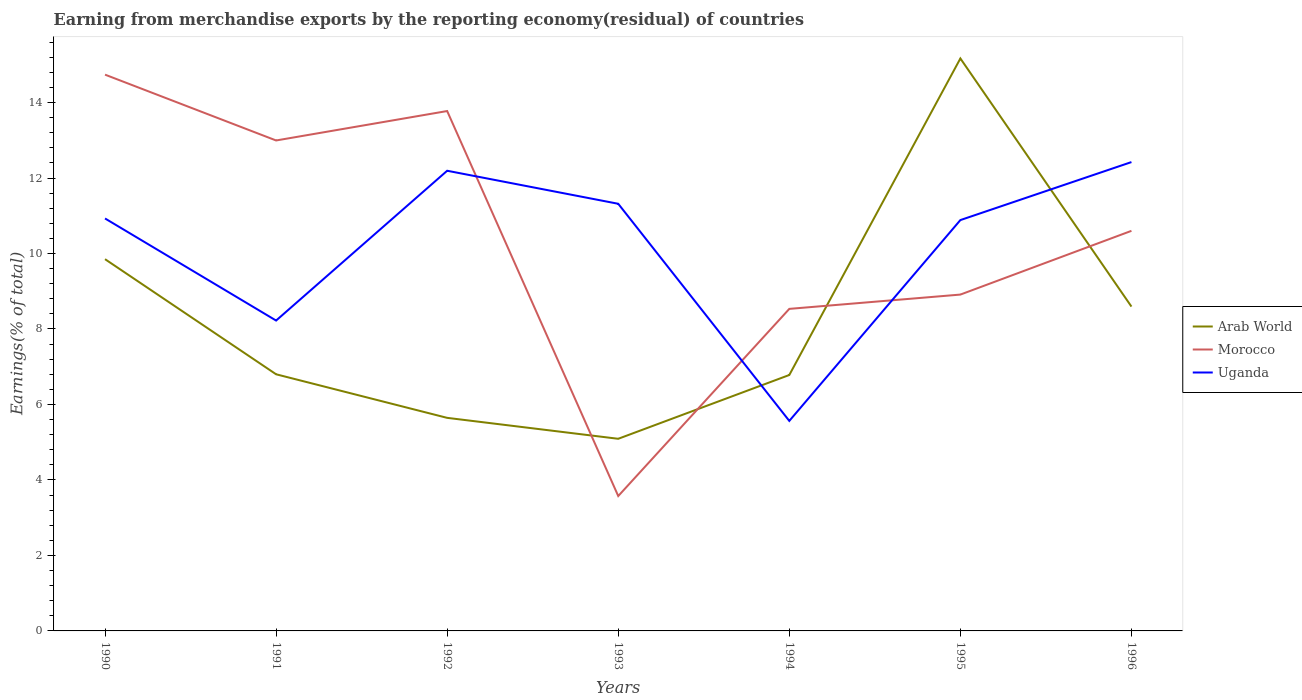How many different coloured lines are there?
Give a very brief answer. 3. Does the line corresponding to Uganda intersect with the line corresponding to Arab World?
Provide a short and direct response. Yes. Is the number of lines equal to the number of legend labels?
Offer a very short reply. Yes. Across all years, what is the maximum percentage of amount earned from merchandise exports in Morocco?
Offer a very short reply. 3.57. In which year was the percentage of amount earned from merchandise exports in Morocco maximum?
Offer a terse response. 1993. What is the total percentage of amount earned from merchandise exports in Morocco in the graph?
Your response must be concise. 5.83. What is the difference between the highest and the second highest percentage of amount earned from merchandise exports in Uganda?
Provide a short and direct response. 6.86. What is the difference between the highest and the lowest percentage of amount earned from merchandise exports in Uganda?
Provide a succinct answer. 5. How many years are there in the graph?
Make the answer very short. 7. Does the graph contain any zero values?
Your answer should be compact. No. How many legend labels are there?
Offer a very short reply. 3. What is the title of the graph?
Offer a terse response. Earning from merchandise exports by the reporting economy(residual) of countries. Does "Macao" appear as one of the legend labels in the graph?
Your response must be concise. No. What is the label or title of the X-axis?
Offer a terse response. Years. What is the label or title of the Y-axis?
Your answer should be compact. Earnings(% of total). What is the Earnings(% of total) of Arab World in 1990?
Keep it short and to the point. 9.85. What is the Earnings(% of total) of Morocco in 1990?
Your answer should be compact. 14.74. What is the Earnings(% of total) of Uganda in 1990?
Offer a terse response. 10.93. What is the Earnings(% of total) in Arab World in 1991?
Your answer should be compact. 6.8. What is the Earnings(% of total) of Morocco in 1991?
Your response must be concise. 12.99. What is the Earnings(% of total) in Uganda in 1991?
Provide a succinct answer. 8.22. What is the Earnings(% of total) in Arab World in 1992?
Offer a very short reply. 5.65. What is the Earnings(% of total) of Morocco in 1992?
Make the answer very short. 13.77. What is the Earnings(% of total) in Uganda in 1992?
Give a very brief answer. 12.19. What is the Earnings(% of total) of Arab World in 1993?
Provide a short and direct response. 5.09. What is the Earnings(% of total) in Morocco in 1993?
Ensure brevity in your answer.  3.57. What is the Earnings(% of total) of Uganda in 1993?
Make the answer very short. 11.32. What is the Earnings(% of total) of Arab World in 1994?
Provide a succinct answer. 6.78. What is the Earnings(% of total) in Morocco in 1994?
Your answer should be very brief. 8.53. What is the Earnings(% of total) of Uganda in 1994?
Your answer should be very brief. 5.56. What is the Earnings(% of total) of Arab World in 1995?
Make the answer very short. 15.17. What is the Earnings(% of total) of Morocco in 1995?
Offer a very short reply. 8.91. What is the Earnings(% of total) in Uganda in 1995?
Your answer should be very brief. 10.89. What is the Earnings(% of total) in Arab World in 1996?
Provide a succinct answer. 8.59. What is the Earnings(% of total) of Morocco in 1996?
Your answer should be compact. 10.6. What is the Earnings(% of total) of Uganda in 1996?
Ensure brevity in your answer.  12.42. Across all years, what is the maximum Earnings(% of total) in Arab World?
Provide a succinct answer. 15.17. Across all years, what is the maximum Earnings(% of total) of Morocco?
Ensure brevity in your answer.  14.74. Across all years, what is the maximum Earnings(% of total) of Uganda?
Offer a very short reply. 12.42. Across all years, what is the minimum Earnings(% of total) of Arab World?
Make the answer very short. 5.09. Across all years, what is the minimum Earnings(% of total) of Morocco?
Offer a terse response. 3.57. Across all years, what is the minimum Earnings(% of total) of Uganda?
Your answer should be very brief. 5.56. What is the total Earnings(% of total) in Arab World in the graph?
Offer a very short reply. 57.93. What is the total Earnings(% of total) in Morocco in the graph?
Give a very brief answer. 73.13. What is the total Earnings(% of total) of Uganda in the graph?
Provide a succinct answer. 71.53. What is the difference between the Earnings(% of total) of Arab World in 1990 and that in 1991?
Make the answer very short. 3.05. What is the difference between the Earnings(% of total) in Morocco in 1990 and that in 1991?
Make the answer very short. 1.74. What is the difference between the Earnings(% of total) of Uganda in 1990 and that in 1991?
Your answer should be compact. 2.7. What is the difference between the Earnings(% of total) in Arab World in 1990 and that in 1992?
Make the answer very short. 4.2. What is the difference between the Earnings(% of total) of Morocco in 1990 and that in 1992?
Provide a short and direct response. 0.96. What is the difference between the Earnings(% of total) in Uganda in 1990 and that in 1992?
Your answer should be compact. -1.26. What is the difference between the Earnings(% of total) in Arab World in 1990 and that in 1993?
Make the answer very short. 4.76. What is the difference between the Earnings(% of total) in Morocco in 1990 and that in 1993?
Provide a succinct answer. 11.16. What is the difference between the Earnings(% of total) of Uganda in 1990 and that in 1993?
Your answer should be compact. -0.39. What is the difference between the Earnings(% of total) of Arab World in 1990 and that in 1994?
Your answer should be compact. 3.07. What is the difference between the Earnings(% of total) of Morocco in 1990 and that in 1994?
Ensure brevity in your answer.  6.21. What is the difference between the Earnings(% of total) in Uganda in 1990 and that in 1994?
Ensure brevity in your answer.  5.36. What is the difference between the Earnings(% of total) of Arab World in 1990 and that in 1995?
Your answer should be compact. -5.32. What is the difference between the Earnings(% of total) in Morocco in 1990 and that in 1995?
Provide a short and direct response. 5.83. What is the difference between the Earnings(% of total) of Uganda in 1990 and that in 1995?
Keep it short and to the point. 0.04. What is the difference between the Earnings(% of total) in Arab World in 1990 and that in 1996?
Give a very brief answer. 1.26. What is the difference between the Earnings(% of total) in Morocco in 1990 and that in 1996?
Ensure brevity in your answer.  4.14. What is the difference between the Earnings(% of total) in Uganda in 1990 and that in 1996?
Give a very brief answer. -1.49. What is the difference between the Earnings(% of total) of Arab World in 1991 and that in 1992?
Provide a succinct answer. 1.15. What is the difference between the Earnings(% of total) of Morocco in 1991 and that in 1992?
Keep it short and to the point. -0.78. What is the difference between the Earnings(% of total) in Uganda in 1991 and that in 1992?
Ensure brevity in your answer.  -3.97. What is the difference between the Earnings(% of total) in Arab World in 1991 and that in 1993?
Provide a succinct answer. 1.71. What is the difference between the Earnings(% of total) in Morocco in 1991 and that in 1993?
Ensure brevity in your answer.  9.42. What is the difference between the Earnings(% of total) in Uganda in 1991 and that in 1993?
Provide a short and direct response. -3.09. What is the difference between the Earnings(% of total) in Arab World in 1991 and that in 1994?
Ensure brevity in your answer.  0.02. What is the difference between the Earnings(% of total) of Morocco in 1991 and that in 1994?
Offer a very short reply. 4.46. What is the difference between the Earnings(% of total) in Uganda in 1991 and that in 1994?
Your answer should be very brief. 2.66. What is the difference between the Earnings(% of total) in Arab World in 1991 and that in 1995?
Keep it short and to the point. -8.37. What is the difference between the Earnings(% of total) of Morocco in 1991 and that in 1995?
Make the answer very short. 4.08. What is the difference between the Earnings(% of total) in Uganda in 1991 and that in 1995?
Your answer should be compact. -2.66. What is the difference between the Earnings(% of total) of Arab World in 1991 and that in 1996?
Your answer should be compact. -1.79. What is the difference between the Earnings(% of total) of Morocco in 1991 and that in 1996?
Your answer should be compact. 2.39. What is the difference between the Earnings(% of total) of Uganda in 1991 and that in 1996?
Provide a succinct answer. -4.2. What is the difference between the Earnings(% of total) of Arab World in 1992 and that in 1993?
Offer a very short reply. 0.55. What is the difference between the Earnings(% of total) of Morocco in 1992 and that in 1993?
Provide a succinct answer. 10.2. What is the difference between the Earnings(% of total) in Uganda in 1992 and that in 1993?
Your answer should be very brief. 0.88. What is the difference between the Earnings(% of total) of Arab World in 1992 and that in 1994?
Provide a succinct answer. -1.14. What is the difference between the Earnings(% of total) of Morocco in 1992 and that in 1994?
Ensure brevity in your answer.  5.24. What is the difference between the Earnings(% of total) in Uganda in 1992 and that in 1994?
Your answer should be very brief. 6.63. What is the difference between the Earnings(% of total) of Arab World in 1992 and that in 1995?
Provide a short and direct response. -9.52. What is the difference between the Earnings(% of total) of Morocco in 1992 and that in 1995?
Offer a terse response. 4.86. What is the difference between the Earnings(% of total) of Uganda in 1992 and that in 1995?
Give a very brief answer. 1.31. What is the difference between the Earnings(% of total) in Arab World in 1992 and that in 1996?
Make the answer very short. -2.95. What is the difference between the Earnings(% of total) in Morocco in 1992 and that in 1996?
Your response must be concise. 3.17. What is the difference between the Earnings(% of total) in Uganda in 1992 and that in 1996?
Give a very brief answer. -0.23. What is the difference between the Earnings(% of total) of Arab World in 1993 and that in 1994?
Offer a very short reply. -1.69. What is the difference between the Earnings(% of total) of Morocco in 1993 and that in 1994?
Offer a terse response. -4.96. What is the difference between the Earnings(% of total) in Uganda in 1993 and that in 1994?
Offer a very short reply. 5.75. What is the difference between the Earnings(% of total) of Arab World in 1993 and that in 1995?
Your answer should be very brief. -10.08. What is the difference between the Earnings(% of total) in Morocco in 1993 and that in 1995?
Give a very brief answer. -5.34. What is the difference between the Earnings(% of total) of Uganda in 1993 and that in 1995?
Your answer should be very brief. 0.43. What is the difference between the Earnings(% of total) in Arab World in 1993 and that in 1996?
Your response must be concise. -3.5. What is the difference between the Earnings(% of total) in Morocco in 1993 and that in 1996?
Offer a very short reply. -7.03. What is the difference between the Earnings(% of total) of Uganda in 1993 and that in 1996?
Ensure brevity in your answer.  -1.1. What is the difference between the Earnings(% of total) of Arab World in 1994 and that in 1995?
Your response must be concise. -8.39. What is the difference between the Earnings(% of total) in Morocco in 1994 and that in 1995?
Your answer should be compact. -0.38. What is the difference between the Earnings(% of total) of Uganda in 1994 and that in 1995?
Offer a terse response. -5.32. What is the difference between the Earnings(% of total) in Arab World in 1994 and that in 1996?
Your answer should be compact. -1.81. What is the difference between the Earnings(% of total) in Morocco in 1994 and that in 1996?
Keep it short and to the point. -2.07. What is the difference between the Earnings(% of total) of Uganda in 1994 and that in 1996?
Give a very brief answer. -6.86. What is the difference between the Earnings(% of total) of Arab World in 1995 and that in 1996?
Provide a short and direct response. 6.57. What is the difference between the Earnings(% of total) in Morocco in 1995 and that in 1996?
Your answer should be compact. -1.69. What is the difference between the Earnings(% of total) in Uganda in 1995 and that in 1996?
Ensure brevity in your answer.  -1.54. What is the difference between the Earnings(% of total) of Arab World in 1990 and the Earnings(% of total) of Morocco in 1991?
Offer a terse response. -3.14. What is the difference between the Earnings(% of total) in Arab World in 1990 and the Earnings(% of total) in Uganda in 1991?
Give a very brief answer. 1.63. What is the difference between the Earnings(% of total) of Morocco in 1990 and the Earnings(% of total) of Uganda in 1991?
Your response must be concise. 6.52. What is the difference between the Earnings(% of total) in Arab World in 1990 and the Earnings(% of total) in Morocco in 1992?
Your response must be concise. -3.92. What is the difference between the Earnings(% of total) of Arab World in 1990 and the Earnings(% of total) of Uganda in 1992?
Ensure brevity in your answer.  -2.34. What is the difference between the Earnings(% of total) of Morocco in 1990 and the Earnings(% of total) of Uganda in 1992?
Give a very brief answer. 2.55. What is the difference between the Earnings(% of total) of Arab World in 1990 and the Earnings(% of total) of Morocco in 1993?
Your response must be concise. 6.28. What is the difference between the Earnings(% of total) of Arab World in 1990 and the Earnings(% of total) of Uganda in 1993?
Make the answer very short. -1.47. What is the difference between the Earnings(% of total) of Morocco in 1990 and the Earnings(% of total) of Uganda in 1993?
Ensure brevity in your answer.  3.42. What is the difference between the Earnings(% of total) in Arab World in 1990 and the Earnings(% of total) in Morocco in 1994?
Provide a short and direct response. 1.32. What is the difference between the Earnings(% of total) in Arab World in 1990 and the Earnings(% of total) in Uganda in 1994?
Keep it short and to the point. 4.29. What is the difference between the Earnings(% of total) in Morocco in 1990 and the Earnings(% of total) in Uganda in 1994?
Offer a very short reply. 9.17. What is the difference between the Earnings(% of total) in Arab World in 1990 and the Earnings(% of total) in Morocco in 1995?
Offer a very short reply. 0.94. What is the difference between the Earnings(% of total) in Arab World in 1990 and the Earnings(% of total) in Uganda in 1995?
Give a very brief answer. -1.04. What is the difference between the Earnings(% of total) in Morocco in 1990 and the Earnings(% of total) in Uganda in 1995?
Offer a very short reply. 3.85. What is the difference between the Earnings(% of total) of Arab World in 1990 and the Earnings(% of total) of Morocco in 1996?
Provide a short and direct response. -0.75. What is the difference between the Earnings(% of total) of Arab World in 1990 and the Earnings(% of total) of Uganda in 1996?
Provide a short and direct response. -2.57. What is the difference between the Earnings(% of total) of Morocco in 1990 and the Earnings(% of total) of Uganda in 1996?
Your answer should be compact. 2.32. What is the difference between the Earnings(% of total) in Arab World in 1991 and the Earnings(% of total) in Morocco in 1992?
Keep it short and to the point. -6.97. What is the difference between the Earnings(% of total) of Arab World in 1991 and the Earnings(% of total) of Uganda in 1992?
Your answer should be very brief. -5.39. What is the difference between the Earnings(% of total) of Morocco in 1991 and the Earnings(% of total) of Uganda in 1992?
Ensure brevity in your answer.  0.8. What is the difference between the Earnings(% of total) in Arab World in 1991 and the Earnings(% of total) in Morocco in 1993?
Make the answer very short. 3.23. What is the difference between the Earnings(% of total) of Arab World in 1991 and the Earnings(% of total) of Uganda in 1993?
Offer a terse response. -4.52. What is the difference between the Earnings(% of total) in Morocco in 1991 and the Earnings(% of total) in Uganda in 1993?
Make the answer very short. 1.68. What is the difference between the Earnings(% of total) of Arab World in 1991 and the Earnings(% of total) of Morocco in 1994?
Provide a succinct answer. -1.73. What is the difference between the Earnings(% of total) in Arab World in 1991 and the Earnings(% of total) in Uganda in 1994?
Keep it short and to the point. 1.24. What is the difference between the Earnings(% of total) of Morocco in 1991 and the Earnings(% of total) of Uganda in 1994?
Your response must be concise. 7.43. What is the difference between the Earnings(% of total) of Arab World in 1991 and the Earnings(% of total) of Morocco in 1995?
Give a very brief answer. -2.11. What is the difference between the Earnings(% of total) in Arab World in 1991 and the Earnings(% of total) in Uganda in 1995?
Your response must be concise. -4.09. What is the difference between the Earnings(% of total) of Morocco in 1991 and the Earnings(% of total) of Uganda in 1995?
Offer a very short reply. 2.11. What is the difference between the Earnings(% of total) in Arab World in 1991 and the Earnings(% of total) in Morocco in 1996?
Offer a very short reply. -3.8. What is the difference between the Earnings(% of total) in Arab World in 1991 and the Earnings(% of total) in Uganda in 1996?
Offer a terse response. -5.62. What is the difference between the Earnings(% of total) in Morocco in 1991 and the Earnings(% of total) in Uganda in 1996?
Your response must be concise. 0.57. What is the difference between the Earnings(% of total) in Arab World in 1992 and the Earnings(% of total) in Morocco in 1993?
Keep it short and to the point. 2.07. What is the difference between the Earnings(% of total) in Arab World in 1992 and the Earnings(% of total) in Uganda in 1993?
Your answer should be compact. -5.67. What is the difference between the Earnings(% of total) of Morocco in 1992 and the Earnings(% of total) of Uganda in 1993?
Keep it short and to the point. 2.46. What is the difference between the Earnings(% of total) of Arab World in 1992 and the Earnings(% of total) of Morocco in 1994?
Ensure brevity in your answer.  -2.89. What is the difference between the Earnings(% of total) of Arab World in 1992 and the Earnings(% of total) of Uganda in 1994?
Provide a succinct answer. 0.08. What is the difference between the Earnings(% of total) in Morocco in 1992 and the Earnings(% of total) in Uganda in 1994?
Give a very brief answer. 8.21. What is the difference between the Earnings(% of total) in Arab World in 1992 and the Earnings(% of total) in Morocco in 1995?
Your answer should be very brief. -3.27. What is the difference between the Earnings(% of total) in Arab World in 1992 and the Earnings(% of total) in Uganda in 1995?
Provide a succinct answer. -5.24. What is the difference between the Earnings(% of total) in Morocco in 1992 and the Earnings(% of total) in Uganda in 1995?
Make the answer very short. 2.89. What is the difference between the Earnings(% of total) of Arab World in 1992 and the Earnings(% of total) of Morocco in 1996?
Offer a very short reply. -4.95. What is the difference between the Earnings(% of total) of Arab World in 1992 and the Earnings(% of total) of Uganda in 1996?
Offer a terse response. -6.78. What is the difference between the Earnings(% of total) of Morocco in 1992 and the Earnings(% of total) of Uganda in 1996?
Offer a terse response. 1.35. What is the difference between the Earnings(% of total) of Arab World in 1993 and the Earnings(% of total) of Morocco in 1994?
Keep it short and to the point. -3.44. What is the difference between the Earnings(% of total) of Arab World in 1993 and the Earnings(% of total) of Uganda in 1994?
Offer a very short reply. -0.47. What is the difference between the Earnings(% of total) of Morocco in 1993 and the Earnings(% of total) of Uganda in 1994?
Your answer should be very brief. -1.99. What is the difference between the Earnings(% of total) in Arab World in 1993 and the Earnings(% of total) in Morocco in 1995?
Provide a short and direct response. -3.82. What is the difference between the Earnings(% of total) in Arab World in 1993 and the Earnings(% of total) in Uganda in 1995?
Provide a short and direct response. -5.79. What is the difference between the Earnings(% of total) of Morocco in 1993 and the Earnings(% of total) of Uganda in 1995?
Your response must be concise. -7.31. What is the difference between the Earnings(% of total) of Arab World in 1993 and the Earnings(% of total) of Morocco in 1996?
Your answer should be compact. -5.51. What is the difference between the Earnings(% of total) of Arab World in 1993 and the Earnings(% of total) of Uganda in 1996?
Ensure brevity in your answer.  -7.33. What is the difference between the Earnings(% of total) of Morocco in 1993 and the Earnings(% of total) of Uganda in 1996?
Ensure brevity in your answer.  -8.85. What is the difference between the Earnings(% of total) in Arab World in 1994 and the Earnings(% of total) in Morocco in 1995?
Offer a terse response. -2.13. What is the difference between the Earnings(% of total) in Arab World in 1994 and the Earnings(% of total) in Uganda in 1995?
Provide a succinct answer. -4.1. What is the difference between the Earnings(% of total) in Morocco in 1994 and the Earnings(% of total) in Uganda in 1995?
Offer a terse response. -2.35. What is the difference between the Earnings(% of total) in Arab World in 1994 and the Earnings(% of total) in Morocco in 1996?
Your answer should be compact. -3.82. What is the difference between the Earnings(% of total) of Arab World in 1994 and the Earnings(% of total) of Uganda in 1996?
Provide a short and direct response. -5.64. What is the difference between the Earnings(% of total) in Morocco in 1994 and the Earnings(% of total) in Uganda in 1996?
Offer a terse response. -3.89. What is the difference between the Earnings(% of total) of Arab World in 1995 and the Earnings(% of total) of Morocco in 1996?
Give a very brief answer. 4.57. What is the difference between the Earnings(% of total) in Arab World in 1995 and the Earnings(% of total) in Uganda in 1996?
Offer a very short reply. 2.75. What is the difference between the Earnings(% of total) of Morocco in 1995 and the Earnings(% of total) of Uganda in 1996?
Your answer should be very brief. -3.51. What is the average Earnings(% of total) in Arab World per year?
Your response must be concise. 8.28. What is the average Earnings(% of total) of Morocco per year?
Provide a short and direct response. 10.45. What is the average Earnings(% of total) in Uganda per year?
Your answer should be very brief. 10.22. In the year 1990, what is the difference between the Earnings(% of total) of Arab World and Earnings(% of total) of Morocco?
Offer a terse response. -4.89. In the year 1990, what is the difference between the Earnings(% of total) of Arab World and Earnings(% of total) of Uganda?
Provide a succinct answer. -1.08. In the year 1990, what is the difference between the Earnings(% of total) of Morocco and Earnings(% of total) of Uganda?
Your answer should be very brief. 3.81. In the year 1991, what is the difference between the Earnings(% of total) of Arab World and Earnings(% of total) of Morocco?
Your response must be concise. -6.19. In the year 1991, what is the difference between the Earnings(% of total) of Arab World and Earnings(% of total) of Uganda?
Keep it short and to the point. -1.42. In the year 1991, what is the difference between the Earnings(% of total) in Morocco and Earnings(% of total) in Uganda?
Make the answer very short. 4.77. In the year 1992, what is the difference between the Earnings(% of total) of Arab World and Earnings(% of total) of Morocco?
Your response must be concise. -8.13. In the year 1992, what is the difference between the Earnings(% of total) of Arab World and Earnings(% of total) of Uganda?
Provide a short and direct response. -6.55. In the year 1992, what is the difference between the Earnings(% of total) in Morocco and Earnings(% of total) in Uganda?
Provide a succinct answer. 1.58. In the year 1993, what is the difference between the Earnings(% of total) in Arab World and Earnings(% of total) in Morocco?
Your response must be concise. 1.52. In the year 1993, what is the difference between the Earnings(% of total) in Arab World and Earnings(% of total) in Uganda?
Your answer should be very brief. -6.23. In the year 1993, what is the difference between the Earnings(% of total) in Morocco and Earnings(% of total) in Uganda?
Provide a succinct answer. -7.74. In the year 1994, what is the difference between the Earnings(% of total) in Arab World and Earnings(% of total) in Morocco?
Make the answer very short. -1.75. In the year 1994, what is the difference between the Earnings(% of total) in Arab World and Earnings(% of total) in Uganda?
Ensure brevity in your answer.  1.22. In the year 1994, what is the difference between the Earnings(% of total) in Morocco and Earnings(% of total) in Uganda?
Give a very brief answer. 2.97. In the year 1995, what is the difference between the Earnings(% of total) of Arab World and Earnings(% of total) of Morocco?
Offer a terse response. 6.26. In the year 1995, what is the difference between the Earnings(% of total) in Arab World and Earnings(% of total) in Uganda?
Your answer should be very brief. 4.28. In the year 1995, what is the difference between the Earnings(% of total) in Morocco and Earnings(% of total) in Uganda?
Provide a succinct answer. -1.97. In the year 1996, what is the difference between the Earnings(% of total) of Arab World and Earnings(% of total) of Morocco?
Keep it short and to the point. -2.01. In the year 1996, what is the difference between the Earnings(% of total) of Arab World and Earnings(% of total) of Uganda?
Your answer should be compact. -3.83. In the year 1996, what is the difference between the Earnings(% of total) in Morocco and Earnings(% of total) in Uganda?
Offer a terse response. -1.82. What is the ratio of the Earnings(% of total) in Arab World in 1990 to that in 1991?
Offer a terse response. 1.45. What is the ratio of the Earnings(% of total) in Morocco in 1990 to that in 1991?
Give a very brief answer. 1.13. What is the ratio of the Earnings(% of total) of Uganda in 1990 to that in 1991?
Provide a short and direct response. 1.33. What is the ratio of the Earnings(% of total) of Arab World in 1990 to that in 1992?
Your response must be concise. 1.74. What is the ratio of the Earnings(% of total) in Morocco in 1990 to that in 1992?
Offer a very short reply. 1.07. What is the ratio of the Earnings(% of total) in Uganda in 1990 to that in 1992?
Give a very brief answer. 0.9. What is the ratio of the Earnings(% of total) of Arab World in 1990 to that in 1993?
Offer a terse response. 1.93. What is the ratio of the Earnings(% of total) of Morocco in 1990 to that in 1993?
Your response must be concise. 4.12. What is the ratio of the Earnings(% of total) in Uganda in 1990 to that in 1993?
Keep it short and to the point. 0.97. What is the ratio of the Earnings(% of total) in Arab World in 1990 to that in 1994?
Provide a succinct answer. 1.45. What is the ratio of the Earnings(% of total) of Morocco in 1990 to that in 1994?
Provide a short and direct response. 1.73. What is the ratio of the Earnings(% of total) in Uganda in 1990 to that in 1994?
Ensure brevity in your answer.  1.96. What is the ratio of the Earnings(% of total) of Arab World in 1990 to that in 1995?
Your answer should be very brief. 0.65. What is the ratio of the Earnings(% of total) in Morocco in 1990 to that in 1995?
Your answer should be compact. 1.65. What is the ratio of the Earnings(% of total) of Arab World in 1990 to that in 1996?
Keep it short and to the point. 1.15. What is the ratio of the Earnings(% of total) in Morocco in 1990 to that in 1996?
Offer a very short reply. 1.39. What is the ratio of the Earnings(% of total) in Uganda in 1990 to that in 1996?
Your answer should be very brief. 0.88. What is the ratio of the Earnings(% of total) of Arab World in 1991 to that in 1992?
Offer a terse response. 1.2. What is the ratio of the Earnings(% of total) in Morocco in 1991 to that in 1992?
Make the answer very short. 0.94. What is the ratio of the Earnings(% of total) of Uganda in 1991 to that in 1992?
Keep it short and to the point. 0.67. What is the ratio of the Earnings(% of total) in Arab World in 1991 to that in 1993?
Ensure brevity in your answer.  1.34. What is the ratio of the Earnings(% of total) of Morocco in 1991 to that in 1993?
Your answer should be very brief. 3.64. What is the ratio of the Earnings(% of total) in Uganda in 1991 to that in 1993?
Your response must be concise. 0.73. What is the ratio of the Earnings(% of total) of Morocco in 1991 to that in 1994?
Your answer should be compact. 1.52. What is the ratio of the Earnings(% of total) in Uganda in 1991 to that in 1994?
Provide a short and direct response. 1.48. What is the ratio of the Earnings(% of total) of Arab World in 1991 to that in 1995?
Provide a succinct answer. 0.45. What is the ratio of the Earnings(% of total) of Morocco in 1991 to that in 1995?
Provide a succinct answer. 1.46. What is the ratio of the Earnings(% of total) in Uganda in 1991 to that in 1995?
Provide a succinct answer. 0.76. What is the ratio of the Earnings(% of total) of Arab World in 1991 to that in 1996?
Provide a succinct answer. 0.79. What is the ratio of the Earnings(% of total) in Morocco in 1991 to that in 1996?
Ensure brevity in your answer.  1.23. What is the ratio of the Earnings(% of total) of Uganda in 1991 to that in 1996?
Ensure brevity in your answer.  0.66. What is the ratio of the Earnings(% of total) of Arab World in 1992 to that in 1993?
Your answer should be compact. 1.11. What is the ratio of the Earnings(% of total) of Morocco in 1992 to that in 1993?
Give a very brief answer. 3.85. What is the ratio of the Earnings(% of total) of Uganda in 1992 to that in 1993?
Offer a terse response. 1.08. What is the ratio of the Earnings(% of total) in Arab World in 1992 to that in 1994?
Keep it short and to the point. 0.83. What is the ratio of the Earnings(% of total) of Morocco in 1992 to that in 1994?
Your answer should be very brief. 1.61. What is the ratio of the Earnings(% of total) in Uganda in 1992 to that in 1994?
Your answer should be compact. 2.19. What is the ratio of the Earnings(% of total) in Arab World in 1992 to that in 1995?
Offer a very short reply. 0.37. What is the ratio of the Earnings(% of total) in Morocco in 1992 to that in 1995?
Make the answer very short. 1.55. What is the ratio of the Earnings(% of total) in Uganda in 1992 to that in 1995?
Provide a succinct answer. 1.12. What is the ratio of the Earnings(% of total) of Arab World in 1992 to that in 1996?
Provide a succinct answer. 0.66. What is the ratio of the Earnings(% of total) in Morocco in 1992 to that in 1996?
Your answer should be very brief. 1.3. What is the ratio of the Earnings(% of total) in Uganda in 1992 to that in 1996?
Your answer should be very brief. 0.98. What is the ratio of the Earnings(% of total) of Arab World in 1993 to that in 1994?
Provide a short and direct response. 0.75. What is the ratio of the Earnings(% of total) of Morocco in 1993 to that in 1994?
Your answer should be very brief. 0.42. What is the ratio of the Earnings(% of total) in Uganda in 1993 to that in 1994?
Give a very brief answer. 2.03. What is the ratio of the Earnings(% of total) of Arab World in 1993 to that in 1995?
Ensure brevity in your answer.  0.34. What is the ratio of the Earnings(% of total) in Morocco in 1993 to that in 1995?
Offer a terse response. 0.4. What is the ratio of the Earnings(% of total) in Uganda in 1993 to that in 1995?
Provide a short and direct response. 1.04. What is the ratio of the Earnings(% of total) in Arab World in 1993 to that in 1996?
Give a very brief answer. 0.59. What is the ratio of the Earnings(% of total) in Morocco in 1993 to that in 1996?
Ensure brevity in your answer.  0.34. What is the ratio of the Earnings(% of total) in Uganda in 1993 to that in 1996?
Ensure brevity in your answer.  0.91. What is the ratio of the Earnings(% of total) of Arab World in 1994 to that in 1995?
Offer a very short reply. 0.45. What is the ratio of the Earnings(% of total) in Morocco in 1994 to that in 1995?
Offer a terse response. 0.96. What is the ratio of the Earnings(% of total) in Uganda in 1994 to that in 1995?
Offer a terse response. 0.51. What is the ratio of the Earnings(% of total) of Arab World in 1994 to that in 1996?
Offer a very short reply. 0.79. What is the ratio of the Earnings(% of total) of Morocco in 1994 to that in 1996?
Provide a short and direct response. 0.81. What is the ratio of the Earnings(% of total) of Uganda in 1994 to that in 1996?
Provide a succinct answer. 0.45. What is the ratio of the Earnings(% of total) of Arab World in 1995 to that in 1996?
Your response must be concise. 1.77. What is the ratio of the Earnings(% of total) in Morocco in 1995 to that in 1996?
Your answer should be very brief. 0.84. What is the ratio of the Earnings(% of total) of Uganda in 1995 to that in 1996?
Provide a short and direct response. 0.88. What is the difference between the highest and the second highest Earnings(% of total) in Arab World?
Keep it short and to the point. 5.32. What is the difference between the highest and the second highest Earnings(% of total) in Morocco?
Give a very brief answer. 0.96. What is the difference between the highest and the second highest Earnings(% of total) in Uganda?
Provide a short and direct response. 0.23. What is the difference between the highest and the lowest Earnings(% of total) of Arab World?
Give a very brief answer. 10.08. What is the difference between the highest and the lowest Earnings(% of total) in Morocco?
Your answer should be compact. 11.16. What is the difference between the highest and the lowest Earnings(% of total) in Uganda?
Give a very brief answer. 6.86. 